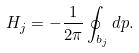Convert formula to latex. <formula><loc_0><loc_0><loc_500><loc_500>H _ { j } = - \frac { 1 } { 2 \pi } \oint _ { b _ { j } } d p .</formula> 